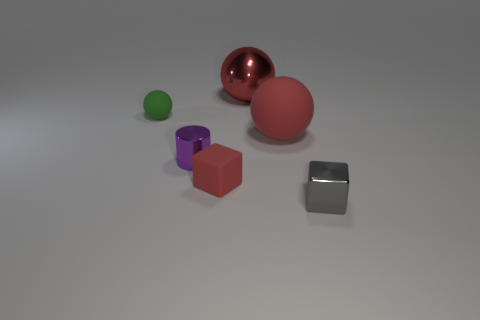Subtract all large shiny spheres. How many spheres are left? 2 Add 1 tiny gray shiny objects. How many objects exist? 7 Subtract all green spheres. How many spheres are left? 2 Subtract all cylinders. How many objects are left? 5 Subtract 1 cylinders. How many cylinders are left? 0 Subtract all green cylinders. How many blue spheres are left? 0 Subtract 0 purple blocks. How many objects are left? 6 Subtract all red cubes. Subtract all cyan cylinders. How many cubes are left? 1 Subtract all large metal spheres. Subtract all red objects. How many objects are left? 2 Add 3 red metal spheres. How many red metal spheres are left? 4 